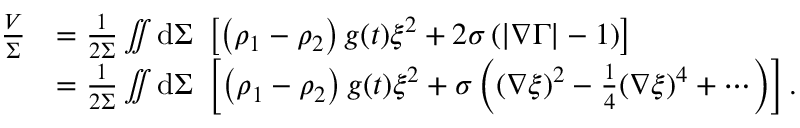Convert formula to latex. <formula><loc_0><loc_0><loc_500><loc_500>\begin{array} { r l } { \frac { V } { \Sigma } } & { = \frac { 1 } { 2 \Sigma } \iint d \Sigma \left [ \left ( \rho _ { 1 } - \rho _ { 2 } \right ) g ( t ) \xi ^ { 2 } + 2 \sigma \left ( | \nabla \Gamma | - 1 \right ) \right ] } \\ & { = \frac { 1 } { 2 \Sigma } \iint d \Sigma \left [ \left ( \rho _ { 1 } - \rho _ { 2 } \right ) g ( t ) \xi ^ { 2 } + \sigma \left ( ( \nabla \xi ) ^ { 2 } - \frac { 1 } { 4 } ( \nabla \xi ) ^ { 4 } + \cdots \right ) \right ] . } \end{array}</formula> 